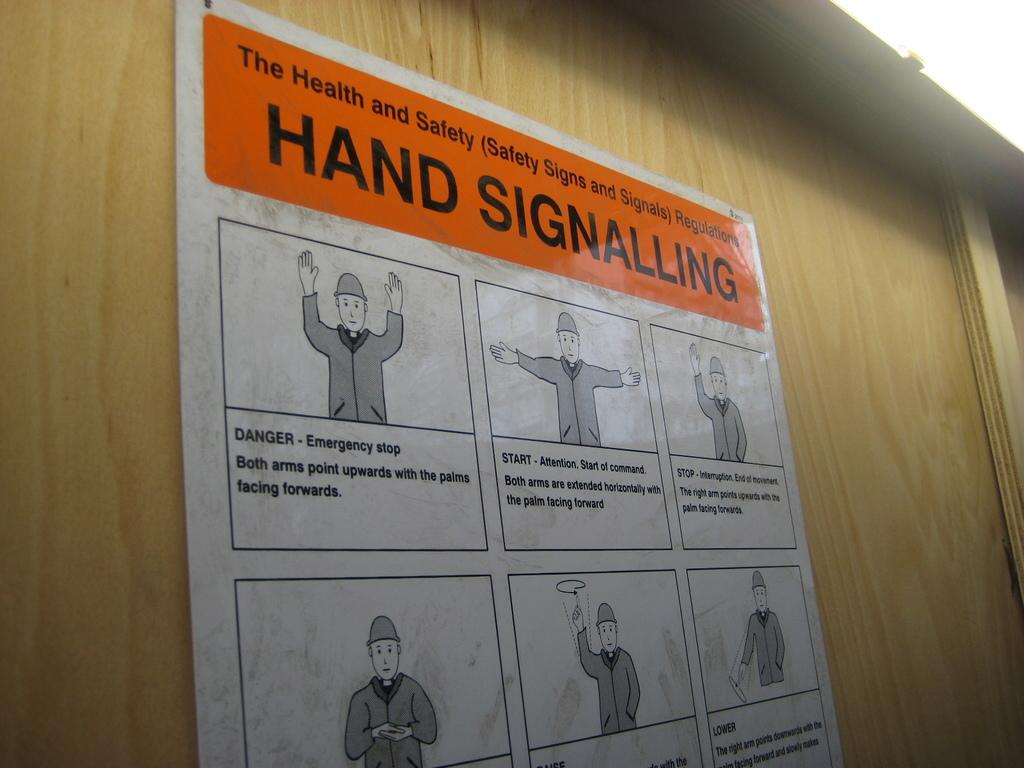<image>
Write a terse but informative summary of the picture. A health and safety poster contains information about hand signaling. 